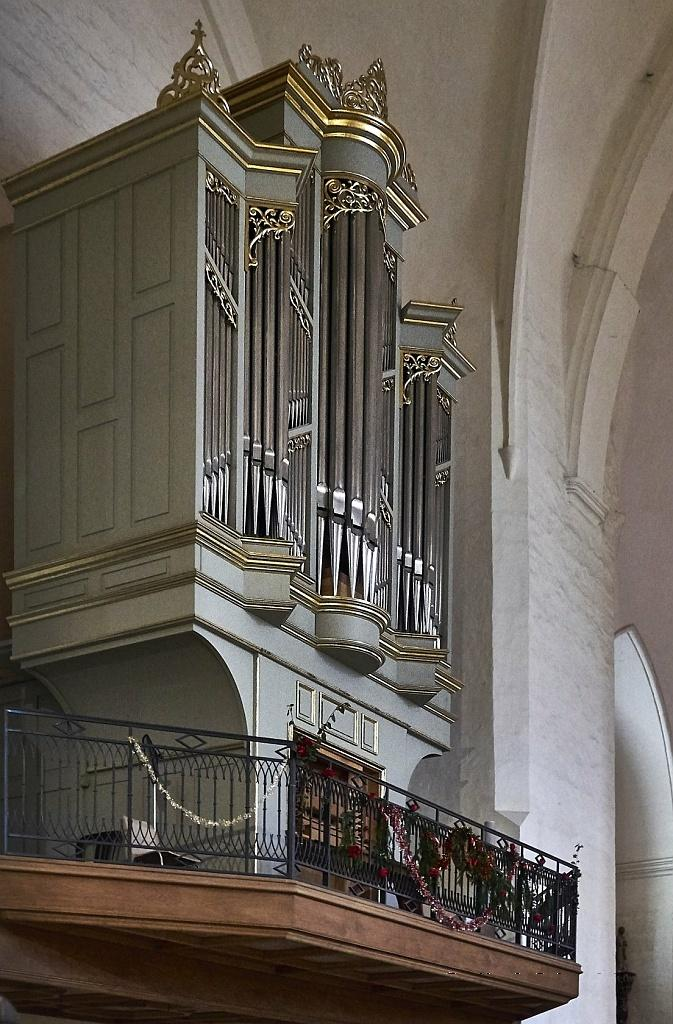What type of subject matter is present in the image? The image contains architecture. Can you describe any specific architectural features in the image? Unfortunately, the provided facts do not mention any specific architectural features. What is visible in the background of the image? There is a wall in the background of the image. How many feet are visible in the image? There are no feet present in the image. What is the color of the stomach in the image? There is no stomach present in the image. 